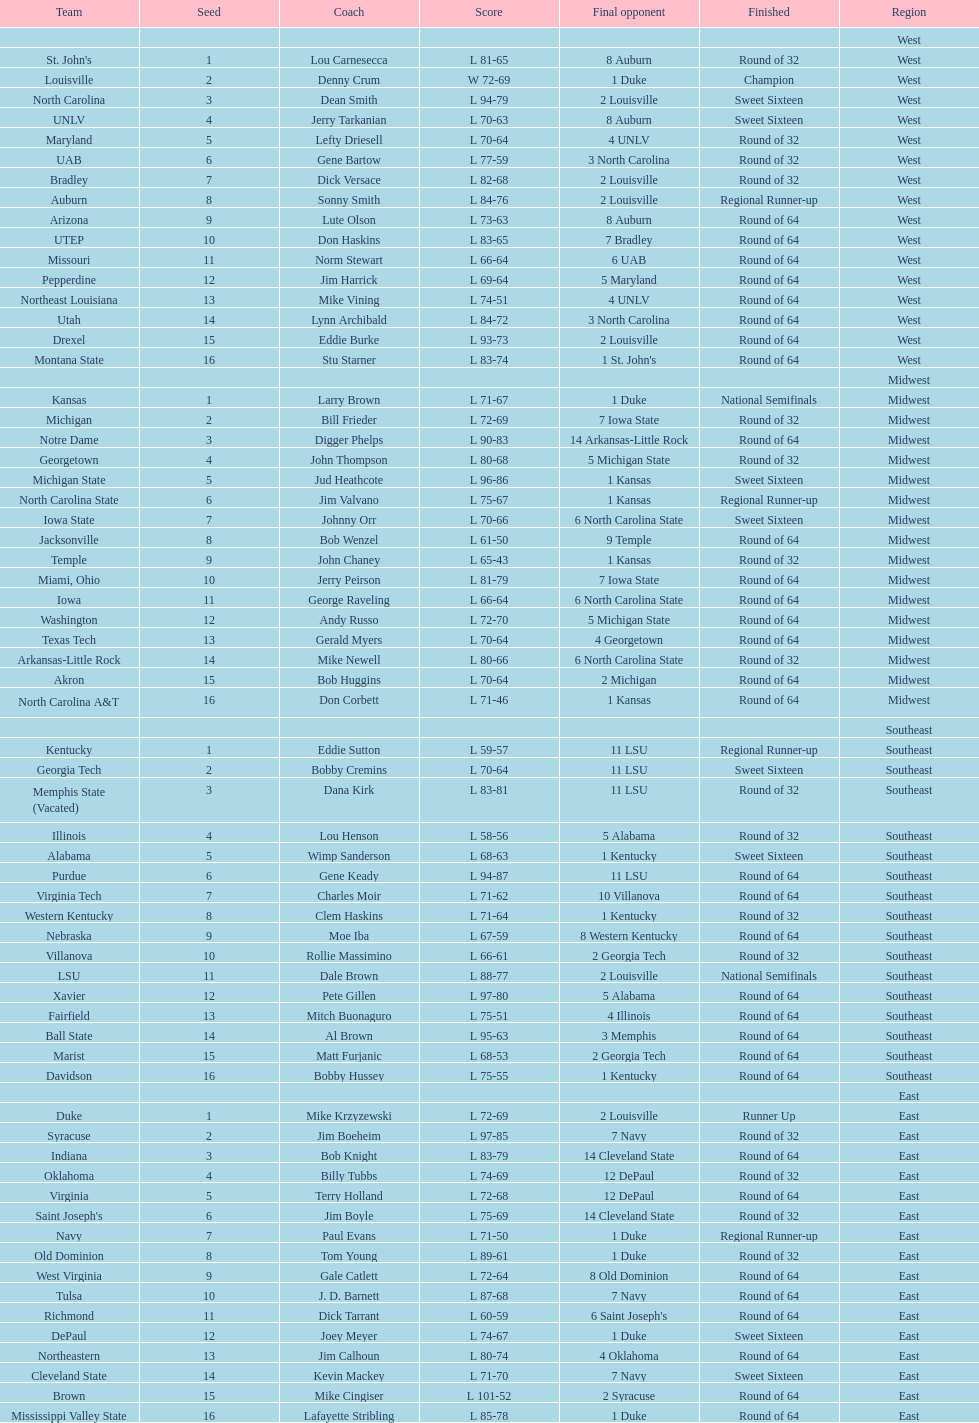Who is the only team from the east region to reach the final round? Duke. 